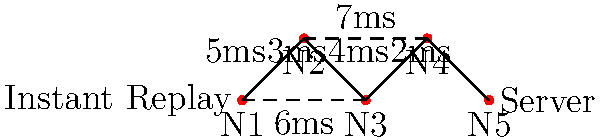In the network diagram above, representing the connection between an instant replay system and the main server, what is the optimal path to minimize latency, and what is the total latency of this path? To find the optimal path with minimal latency, we need to consider all possible routes from the Instant Replay system (N1) to the Server (N5) and calculate their total latencies:

1. Path 1: N1 → N2 → N3 → N4 → N5
   Latency = 5ms + 3ms + 4ms + 2ms = 14ms

2. Path 2: N1 → N2 → N4 → N5
   Latency = 5ms + 7ms + 2ms = 14ms

3. Path 3: N1 → N3 → N4 → N5
   Latency = 6ms + 4ms + 2ms = 12ms

The optimal path is the one with the lowest total latency, which is Path 3 (N1 → N3 → N4 → N5) with a total latency of 12ms.

This path utilizes the direct connection between N1 and N3, which has a lower latency (6ms) compared to going through N2 (5ms + 3ms = 8ms). It then follows the most direct route to the server through N4 and N5.
Answer: N1 → N3 → N4 → N5; 12ms 